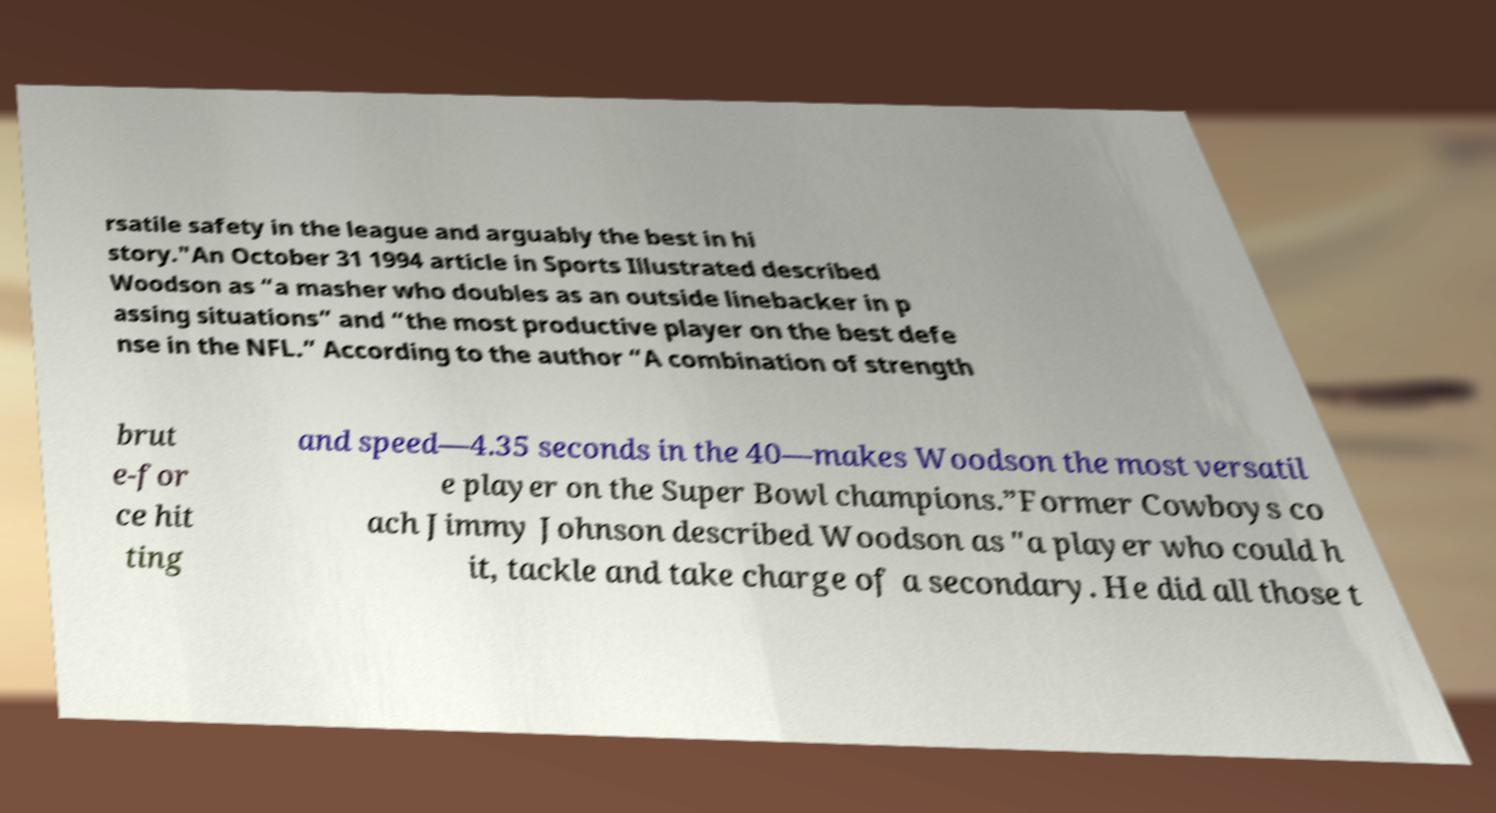I need the written content from this picture converted into text. Can you do that? rsatile safety in the league and arguably the best in hi story."An October 31 1994 article in Sports Illustrated described Woodson as “a masher who doubles as an outside linebacker in p assing situations” and “the most productive player on the best defe nse in the NFL.” According to the author “A combination of strength brut e-for ce hit ting and speed—4.35 seconds in the 40—makes Woodson the most versatil e player on the Super Bowl champions.”Former Cowboys co ach Jimmy Johnson described Woodson as "a player who could h it, tackle and take charge of a secondary. He did all those t 